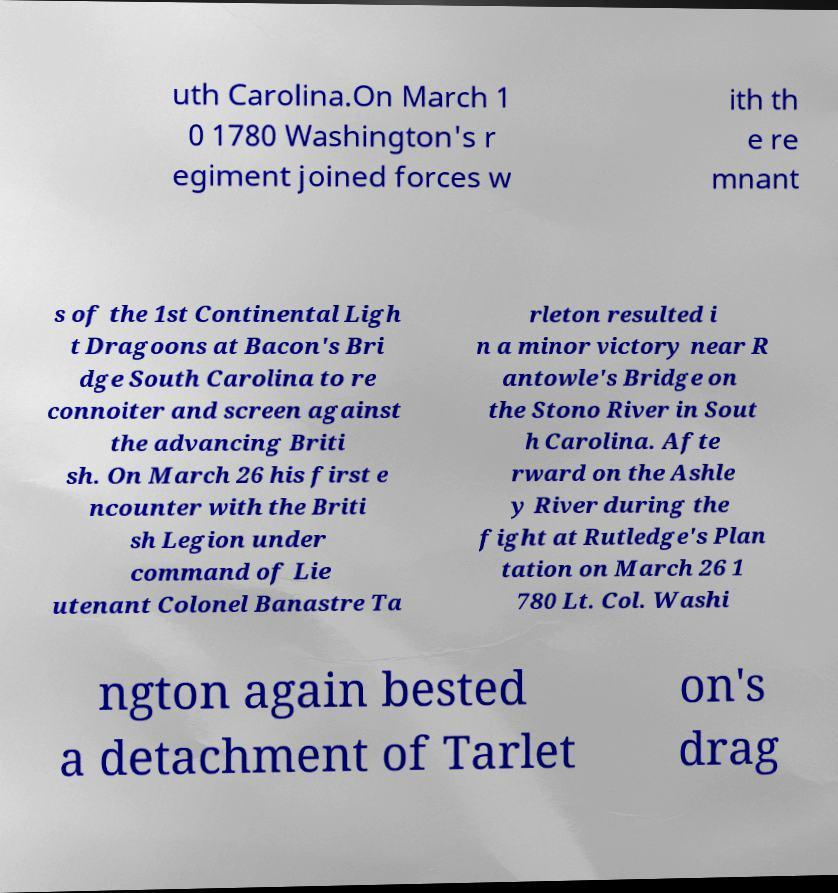Could you extract and type out the text from this image? uth Carolina.On March 1 0 1780 Washington's r egiment joined forces w ith th e re mnant s of the 1st Continental Ligh t Dragoons at Bacon's Bri dge South Carolina to re connoiter and screen against the advancing Briti sh. On March 26 his first e ncounter with the Briti sh Legion under command of Lie utenant Colonel Banastre Ta rleton resulted i n a minor victory near R antowle's Bridge on the Stono River in Sout h Carolina. Afte rward on the Ashle y River during the fight at Rutledge's Plan tation on March 26 1 780 Lt. Col. Washi ngton again bested a detachment of Tarlet on's drag 